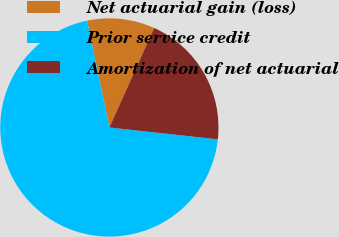Convert chart. <chart><loc_0><loc_0><loc_500><loc_500><pie_chart><fcel>Net actuarial gain (loss)<fcel>Prior service credit<fcel>Amortization of net actuarial<nl><fcel>10.0%<fcel>70.0%<fcel>20.0%<nl></chart> 